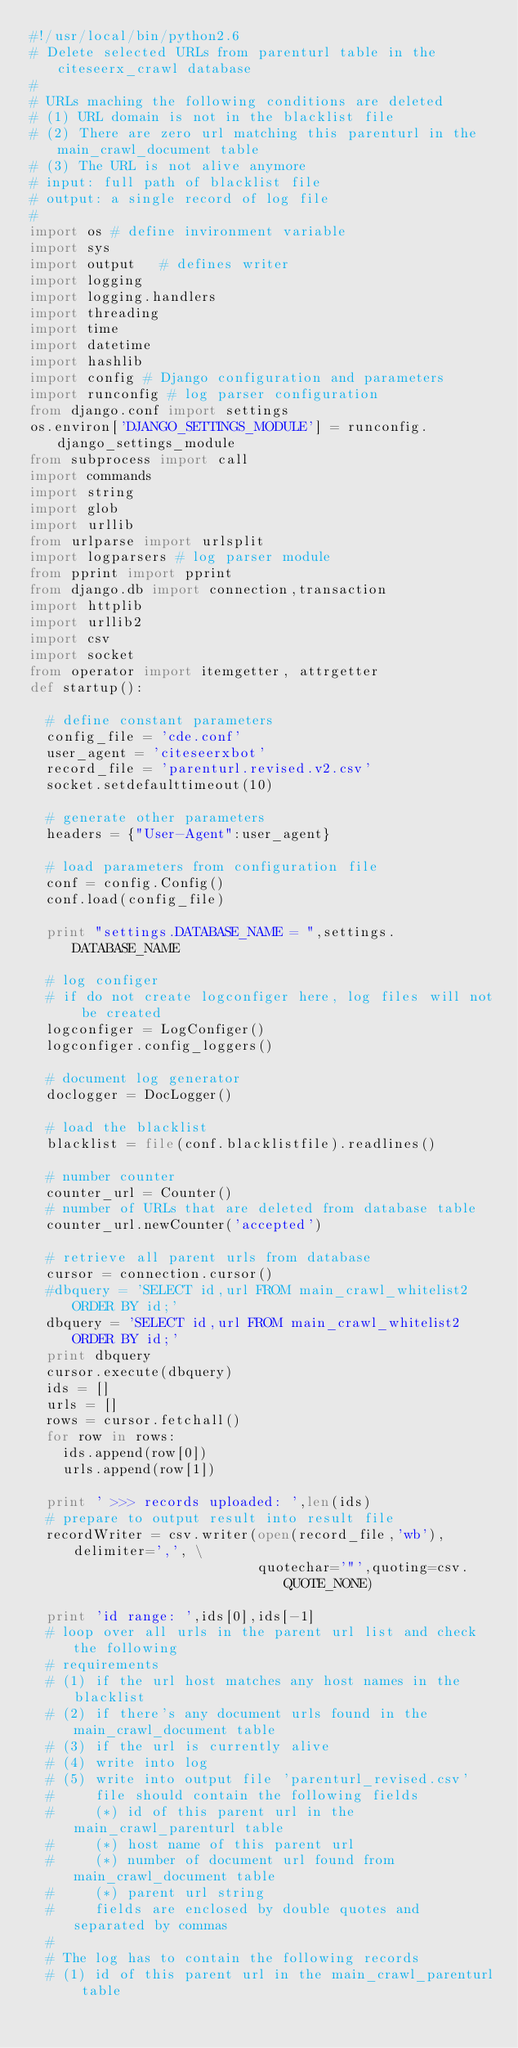<code> <loc_0><loc_0><loc_500><loc_500><_Python_>#!/usr/local/bin/python2.6
# Delete selected URLs from parenturl table in the citeseerx_crawl database
#
# URLs maching the following conditions are deleted
# (1) URL domain is not in the blacklist file
# (2) There are zero url matching this parenturl in the main_crawl_document table
# (3) The URL is not alive anymore
# input: full path of blacklist file
# output: a single record of log file
# 
import os # define invironment variable
import sys 
import output   # defines writer
import logging 
import logging.handlers
import threading
import time
import datetime
import hashlib
import config # Django configuration and parameters
import runconfig # log parser configuration
from django.conf import settings
os.environ['DJANGO_SETTINGS_MODULE'] = runconfig.django_settings_module
from subprocess import call
import commands
import string 
import glob
import urllib
from urlparse import urlsplit
import logparsers # log parser module
from pprint import pprint
from django.db import connection,transaction
import httplib
import urllib2
import csv
import socket
from operator import itemgetter, attrgetter
def startup():

  # define constant parameters
  config_file = 'cde.conf'
  user_agent = 'citeseerxbot'
  record_file = 'parenturl.revised.v2.csv'
  socket.setdefaulttimeout(10)

  # generate other parameters
  headers = {"User-Agent":user_agent}

  # load parameters from configuration file
  conf = config.Config()
  conf.load(config_file)

  print "settings.DATABASE_NAME = ",settings.DATABASE_NAME

  # log configer
  # if do not create logconfiger here, log files will not be created
  logconfiger = LogConfiger()
  logconfiger.config_loggers()

  # document log generator
  doclogger = DocLogger()

  # load the blacklist
  blacklist = file(conf.blacklistfile).readlines()

  # number counter
  counter_url = Counter()
  # number of URLs that are deleted from database table
  counter_url.newCounter('accepted')

  # retrieve all parent urls from database
  cursor = connection.cursor()
  #dbquery = 'SELECT id,url FROM main_crawl_whitelist2 ORDER BY id;'
  dbquery = 'SELECT id,url FROM main_crawl_whitelist2 ORDER BY id;'
  print dbquery
  cursor.execute(dbquery)
  ids = []
  urls = [] 
  rows = cursor.fetchall()
  for row in rows:
    ids.append(row[0])
    urls.append(row[1])

  print ' >>> records uploaded: ',len(ids)
  # prepare to output result into result file
  recordWriter = csv.writer(open(record_file,'wb'),delimiter=',', \
                            quotechar='"',quoting=csv.QUOTE_NONE)
  
  print 'id range: ',ids[0],ids[-1]
  # loop over all urls in the parent url list and check the following
  # requirements
  # (1) if the url host matches any host names in the blacklist
  # (2) if there's any document urls found in the main_crawl_document table
  # (3) if the url is currently alive
  # (4) write into log 
  # (5) write into output file 'parenturl_revised.csv'
  #     file should contain the following fields
  #     (*) id of this parent url in the main_crawl_parenturl table
  #     (*) host name of this parent url
  #     (*) number of document url found from main_crawl_document table
  #     (*) parent url string
  #     fields are enclosed by double quotes and separated by commas
  # 
  # The log has to contain the following records
  # (1) id of this parent url in the main_crawl_parenturl table</code> 